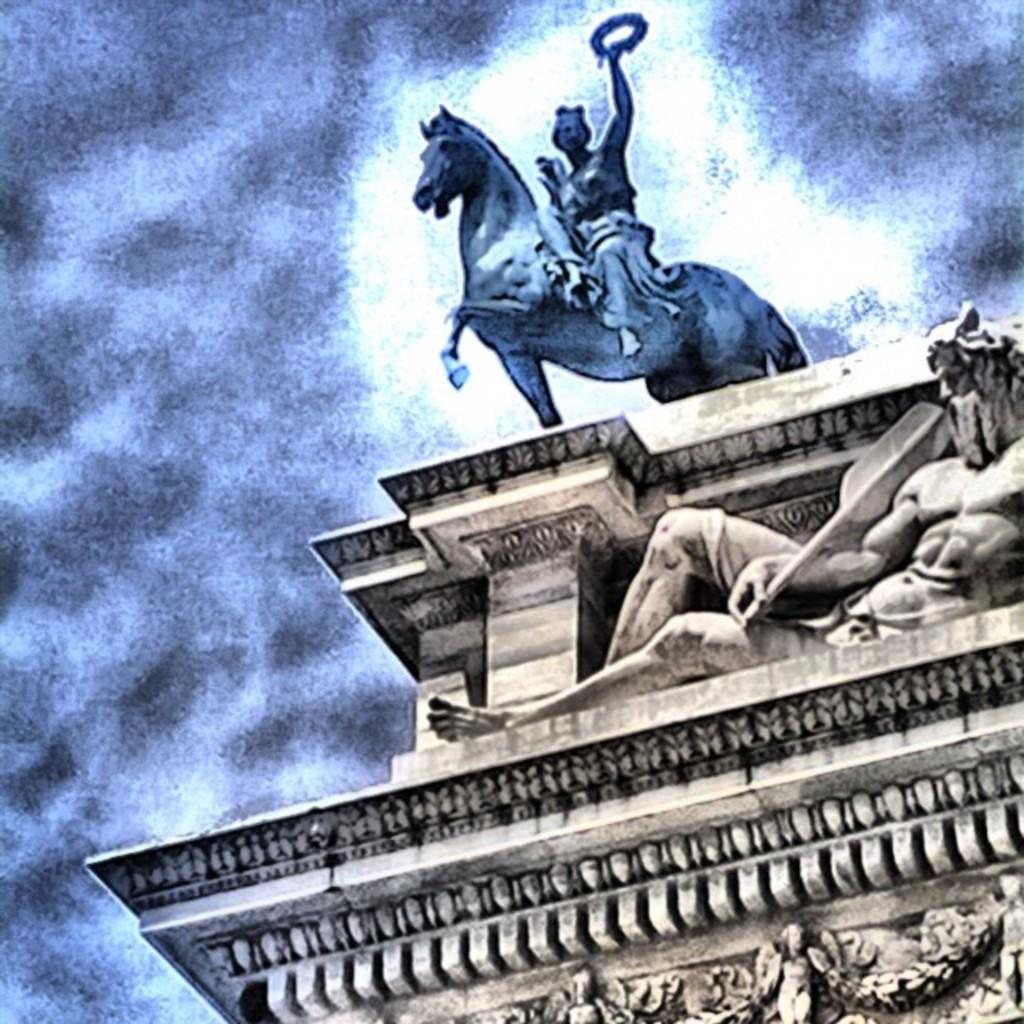What is the main subject of the image? The main subject of the image is a statue of a person. What is the person in the statue doing? The person is sitting on a horse. What is the person holding in his hand? The person is holding an object in his hand. What other sculpture can be seen in the image? There is a sculpture on the wall below the statue. What type of mass can be seen causing a shock in the image? There is no mass or shock present in the image; it features a statue of a person sitting on a horse and holding an object, along with a sculpture on the wall below. 